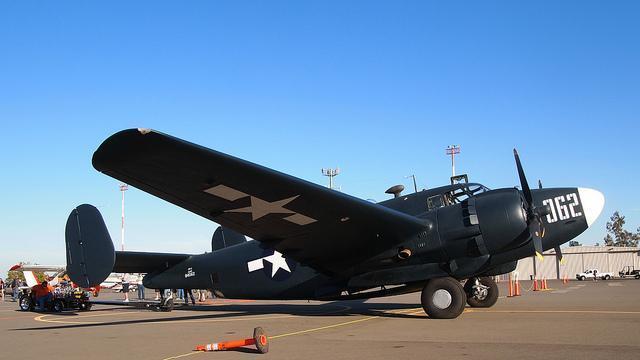How many bows are on the cake but not the shoes?
Give a very brief answer. 0. 